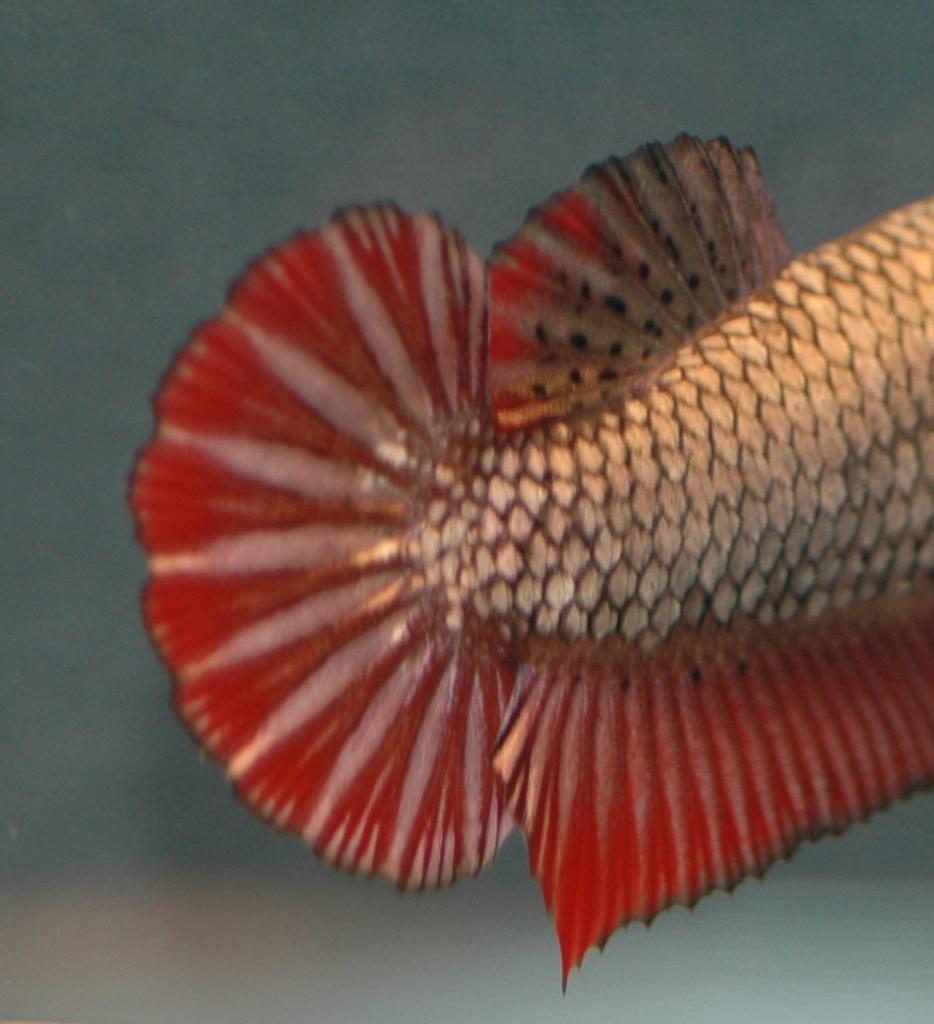Please provide a concise description of this image. In this image we can see the back part of a fish. 